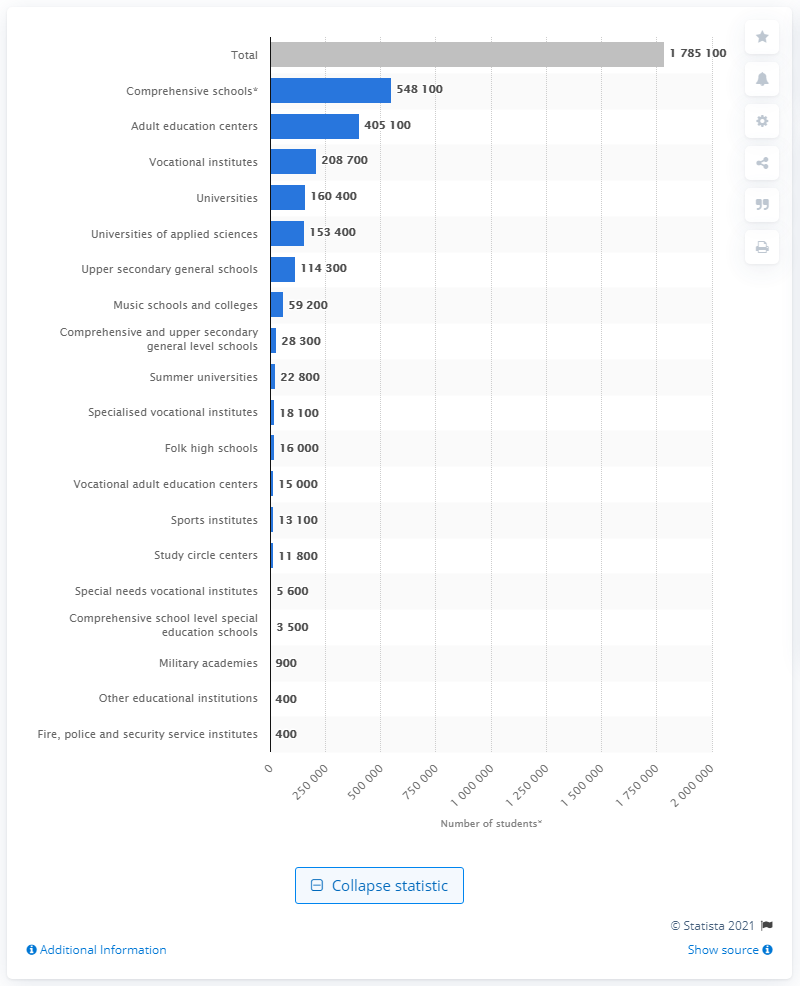Specify some key components in this picture. There were 405,100 students enrolled in adult education centers in Finland in 2020. 